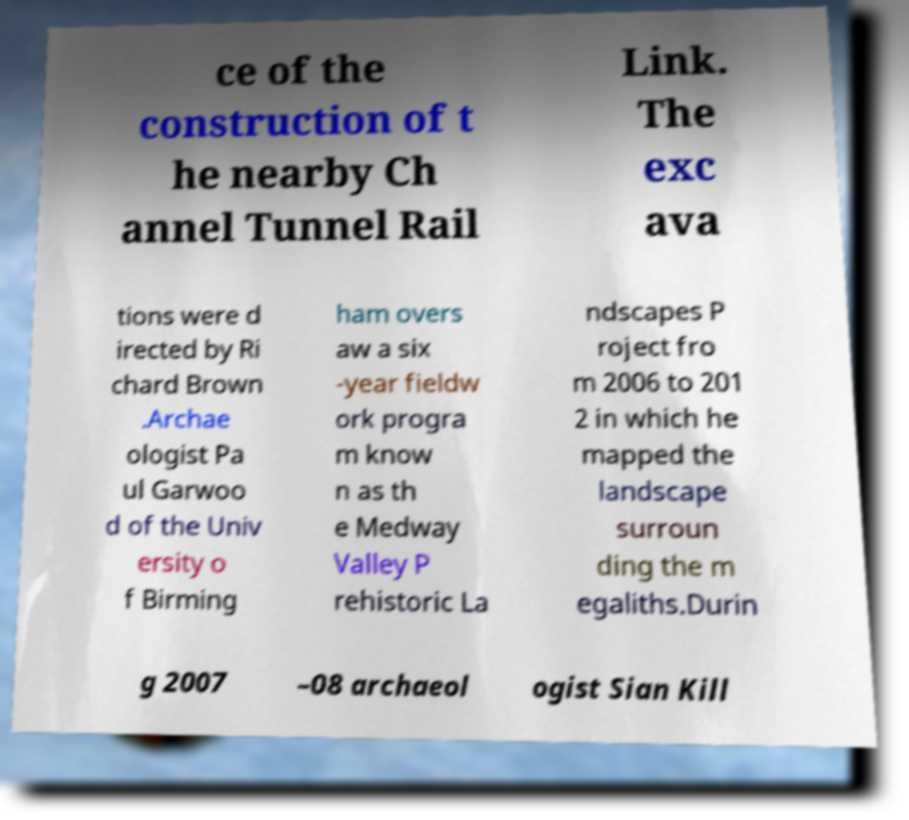For documentation purposes, I need the text within this image transcribed. Could you provide that? ce of the construction of t he nearby Ch annel Tunnel Rail Link. The exc ava tions were d irected by Ri chard Brown .Archae ologist Pa ul Garwoo d of the Univ ersity o f Birming ham overs aw a six -year fieldw ork progra m know n as th e Medway Valley P rehistoric La ndscapes P roject fro m 2006 to 201 2 in which he mapped the landscape surroun ding the m egaliths.Durin g 2007 –08 archaeol ogist Sian Kill 